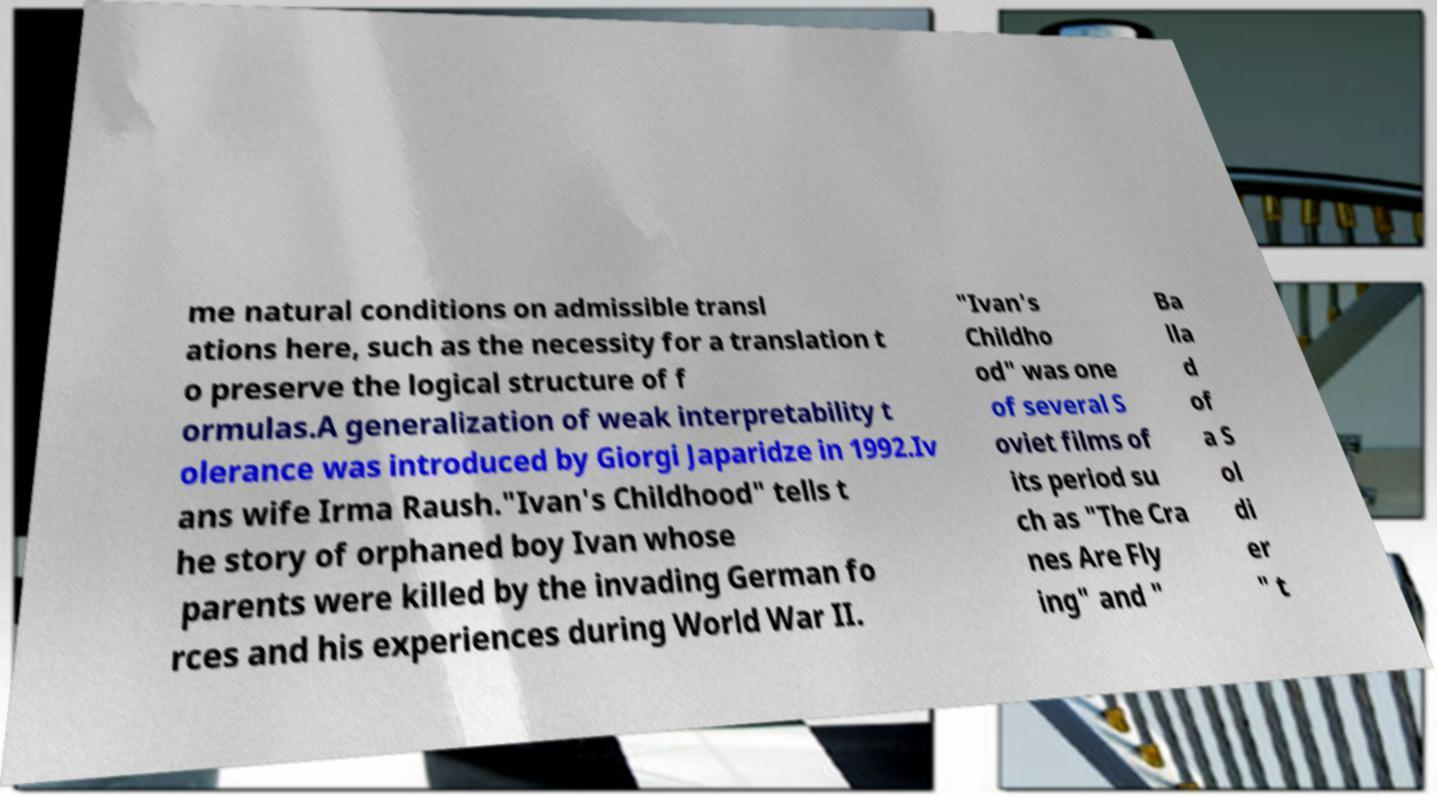Can you read and provide the text displayed in the image?This photo seems to have some interesting text. Can you extract and type it out for me? me natural conditions on admissible transl ations here, such as the necessity for a translation t o preserve the logical structure of f ormulas.A generalization of weak interpretability t olerance was introduced by Giorgi Japaridze in 1992.Iv ans wife Irma Raush."Ivan's Childhood" tells t he story of orphaned boy Ivan whose parents were killed by the invading German fo rces and his experiences during World War II. "Ivan's Childho od" was one of several S oviet films of its period su ch as "The Cra nes Are Fly ing" and " Ba lla d of a S ol di er " t 